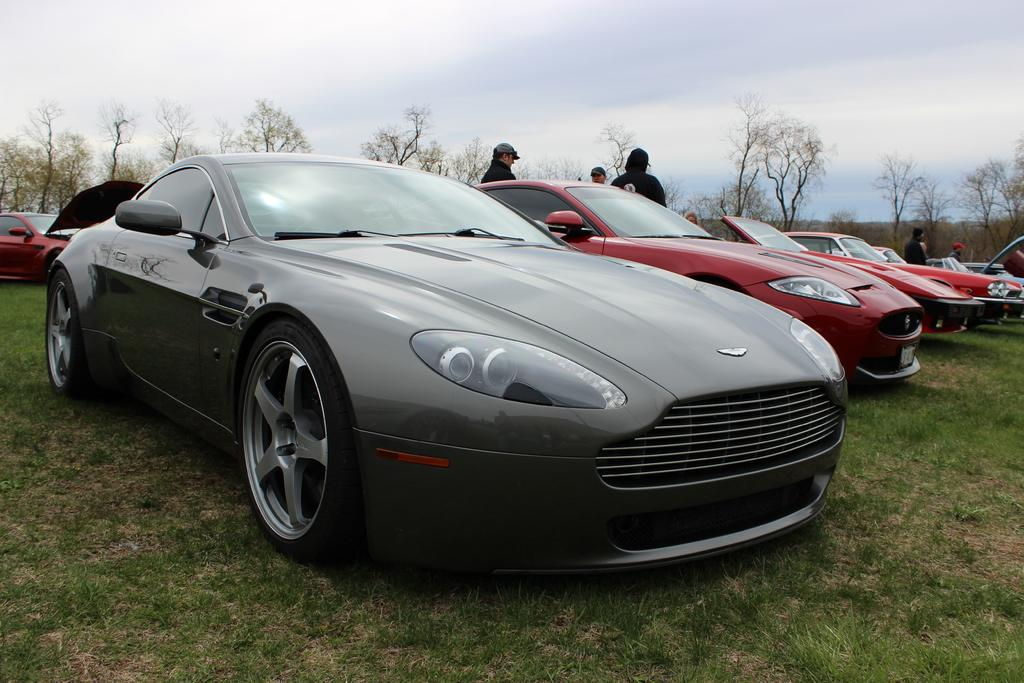What is located on the grass in the image? There are vehicles on the grass in the image. What else can be seen in the image besides the vehicles? There is a group of people standing in the image. What type of natural elements are present in the image? There are trees in the image. What can be seen in the distance in the image? The sky is visible in the background of the image. How many beds are visible in the image? There are no beds present in the image. What type of decision can be seen being made by the group of people in the image? There is no decision-making process depicted in the image; it only shows a group of people standing and vehicles on the grass. 